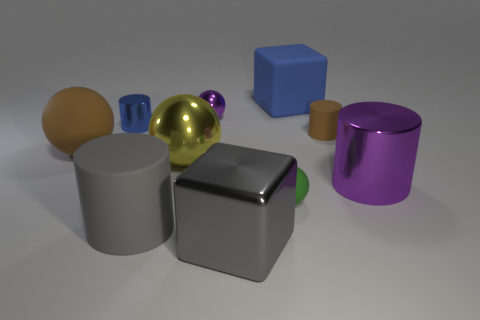Subtract all spheres. How many objects are left? 6 Add 9 brown rubber spheres. How many brown rubber spheres are left? 10 Add 8 tiny matte cylinders. How many tiny matte cylinders exist? 9 Subtract 0 green cubes. How many objects are left? 10 Subtract all large blue blocks. Subtract all gray cubes. How many objects are left? 8 